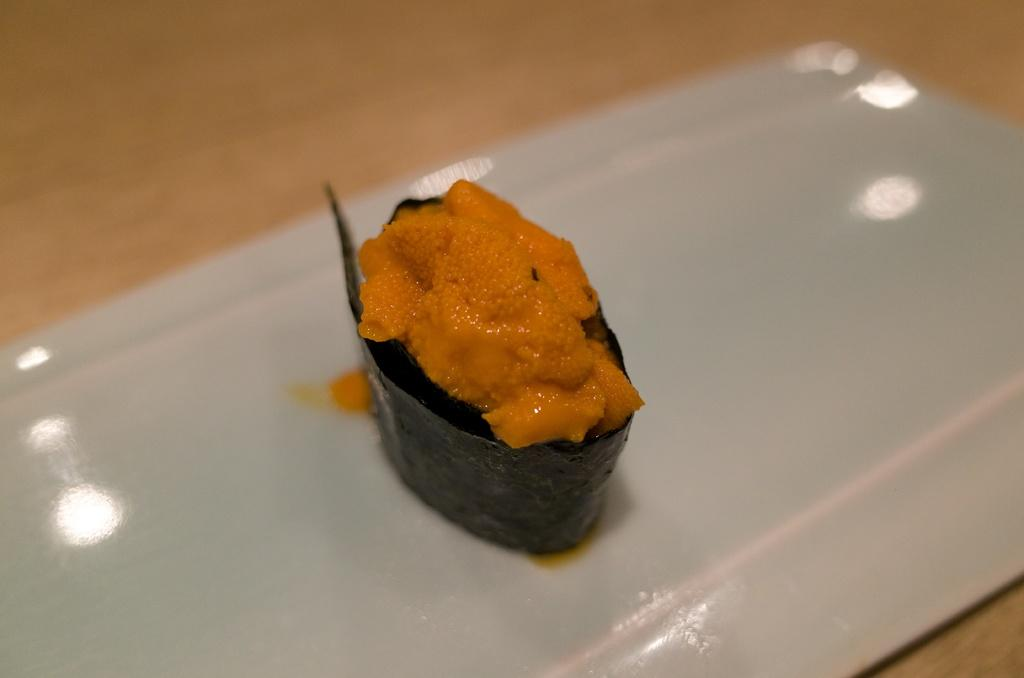What is on the plate in the image? There is a food item on a plate in the image. What color is the plate? The plate is white in color. Where is the plate located in the image? The plate is on a wooden board. What type of brush is used to paint the pot in the image? There is no pot or brush present in the image. 